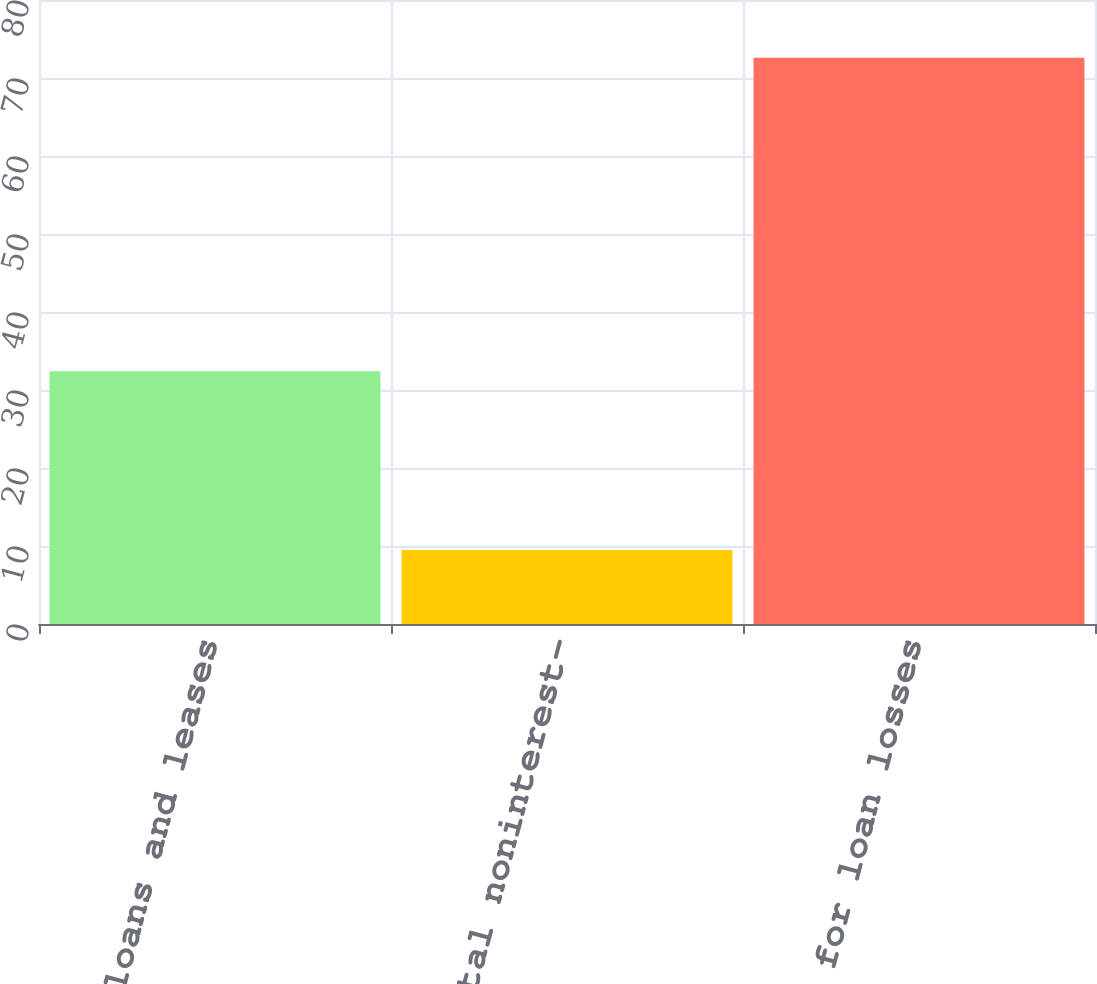<chart> <loc_0><loc_0><loc_500><loc_500><bar_chart><fcel>Average net loans and leases<fcel>Average total noninterest-<fcel>Provision for loan losses<nl><fcel>32.4<fcel>9.5<fcel>72.6<nl></chart> 